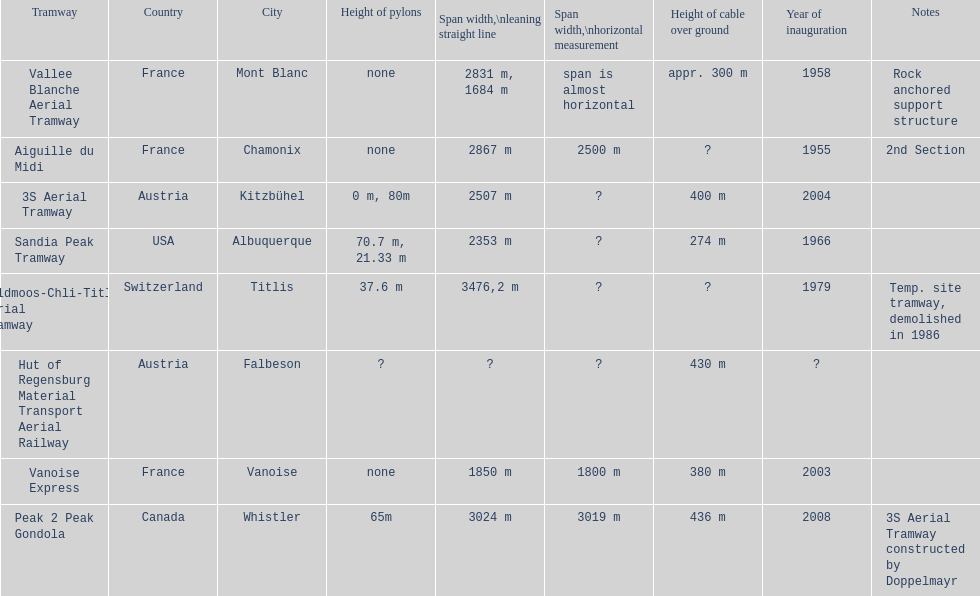Parse the full table. {'header': ['Tramway', 'Country', 'City', 'Height of pylons', 'Span\xa0width,\\nleaning straight line', 'Span width,\\nhorizontal measurement', 'Height of cable over ground', 'Year of inauguration', 'Notes'], 'rows': [['Vallee Blanche Aerial Tramway', 'France', 'Mont Blanc', 'none', '2831 m, 1684 m', 'span is almost horizontal', 'appr. 300 m', '1958', 'Rock anchored support structure'], ['Aiguille du Midi', 'France', 'Chamonix', 'none', '2867 m', '2500 m', '?', '1955', '2nd Section'], ['3S Aerial Tramway', 'Austria', 'Kitzbühel', '0 m, 80m', '2507 m', '?', '400 m', '2004', ''], ['Sandia Peak Tramway', 'USA', 'Albuquerque', '70.7 m, 21.33 m', '2353 m', '?', '274 m', '1966', ''], ['Feldmoos-Chli-Titlis Aerial Tramway', 'Switzerland', 'Titlis', '37.6 m', '3476,2 m', '?', '?', '1979', 'Temp. site tramway, demolished in 1986'], ['Hut of Regensburg Material Transport Aerial Railway', 'Austria', 'Falbeson', '?', '?', '?', '430 m', '?', ''], ['Vanoise Express', 'France', 'Vanoise', 'none', '1850 m', '1800 m', '380 m', '2003', ''], ['Peak 2 Peak Gondola', 'Canada', 'Whistler', '65m', '3024 m', '3019 m', '436 m', '2008', '3S Aerial Tramway constructed by Doppelmayr']]} Was the peak 2 peak gondola inaugurated before the vanoise express? No. 